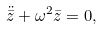Convert formula to latex. <formula><loc_0><loc_0><loc_500><loc_500>\ddot { \bar { z } } + \omega ^ { 2 } \bar { z } = 0 ,</formula> 